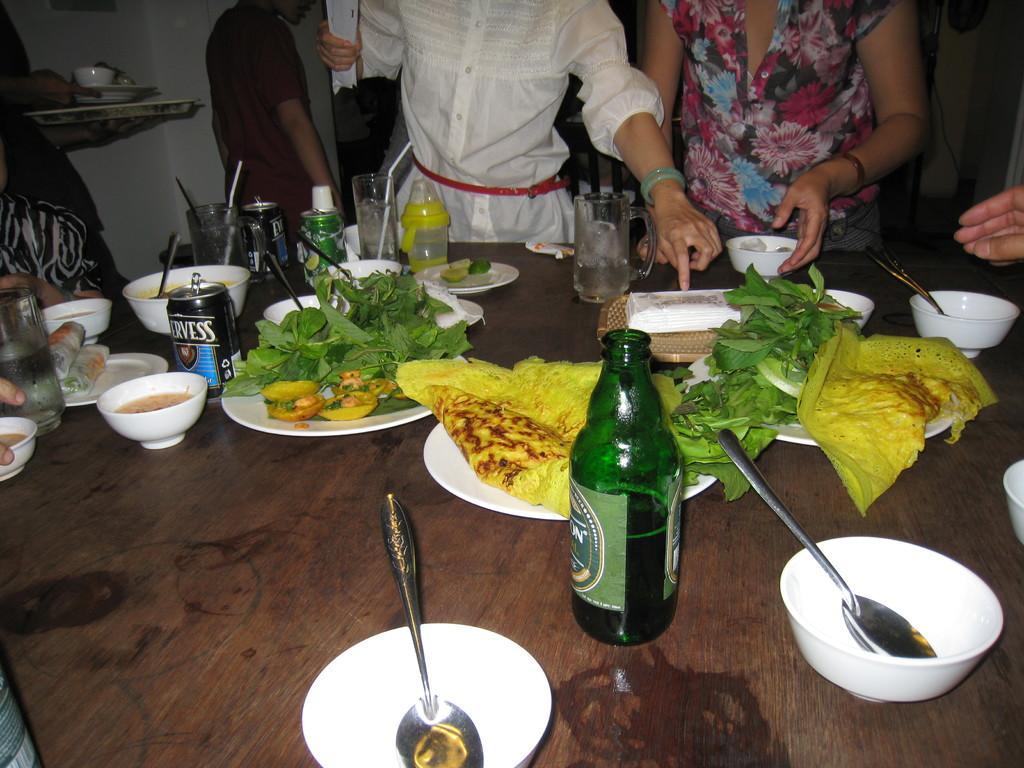Describe this image in one or two sentences. Here we can see a table full of food present and here we can see a group of people standing and they are here to eat the food 